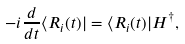Convert formula to latex. <formula><loc_0><loc_0><loc_500><loc_500>- i \frac { d } { d t } \langle R _ { i } ( t ) | = \langle R _ { i } ( t ) | H ^ { \dagger } ,</formula> 